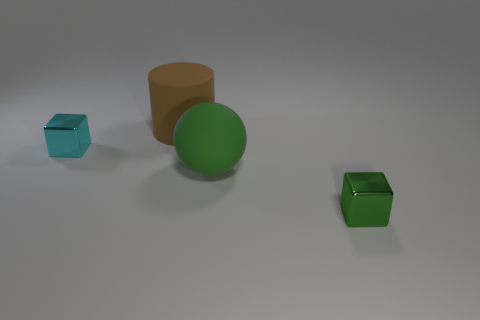Add 4 small cyan cubes. How many objects exist? 8 Subtract all balls. How many objects are left? 3 Add 4 metallic cubes. How many metallic cubes exist? 6 Subtract 0 brown blocks. How many objects are left? 4 Subtract all green objects. Subtract all large green balls. How many objects are left? 1 Add 3 balls. How many balls are left? 4 